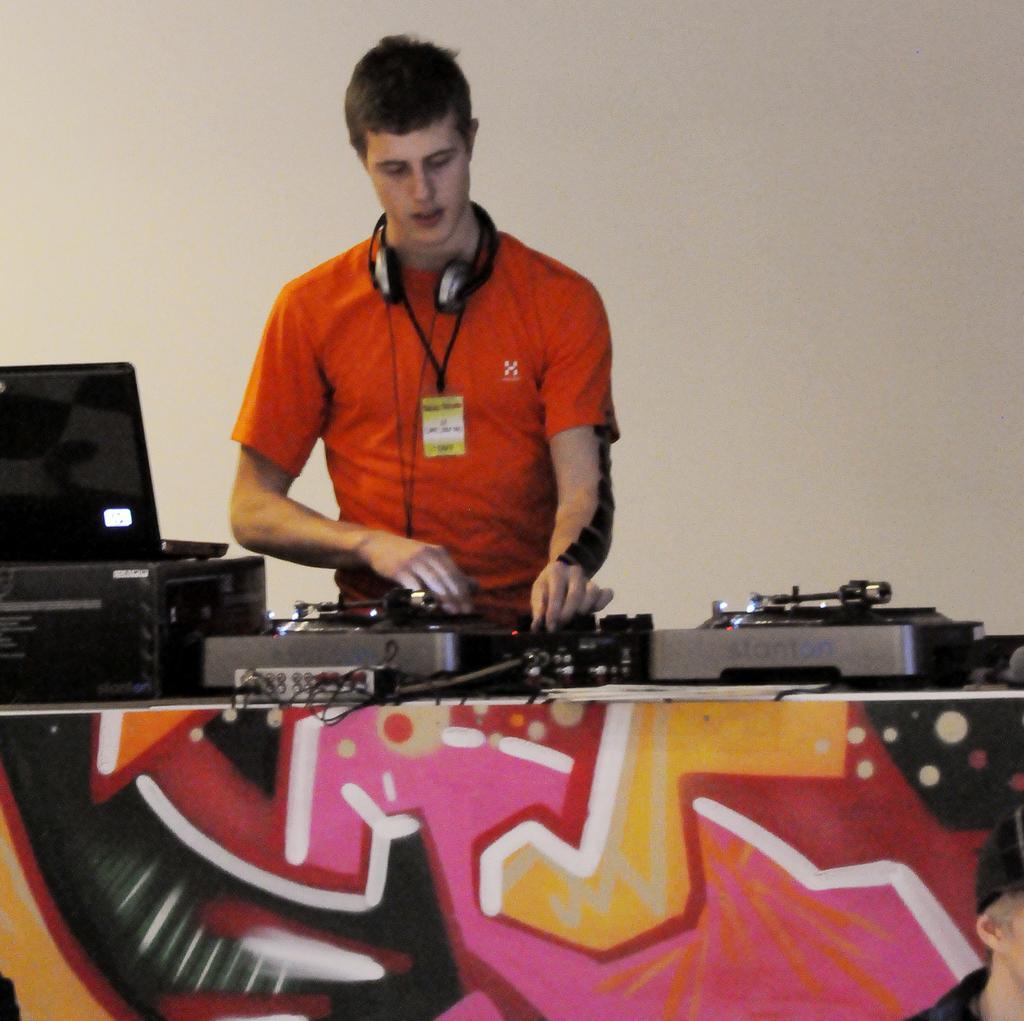How would you summarize this image in a sentence or two? In this image we can see a man wearing the headset standing beside a table containing a laptop, wires and some devices on it. On the backside we can see a wall. At the bottom right we can see a person. 